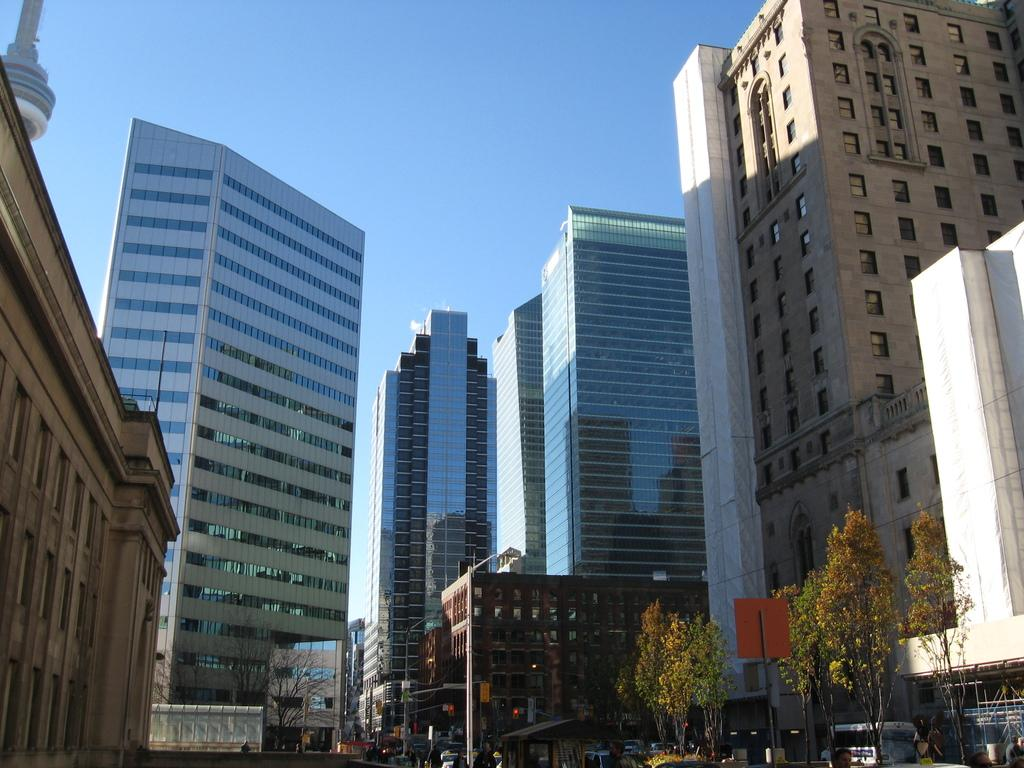What type of structures can be seen in the image? There are buildings in the image. What feature can be observed on the buildings? There are windows visible in the image. What type of vegetation is present in the image? There are trees in the image. What type of signs are visible in the image? There are signboards in the image. What type of vertical structures are present in the image? There are poles in the image. What type of establishments can be seen in the image? There are stores in the image. What is the color of the sky in the image? The sky is blue and white in color. What type of attraction can be seen in the image? There is no specific attraction mentioned or visible in the image; it primarily features buildings, trees, and signboards. How does the image indicate that people should stop? The image does not contain any signs or signals that instruct people to stop; it is a static representation of a scene. 